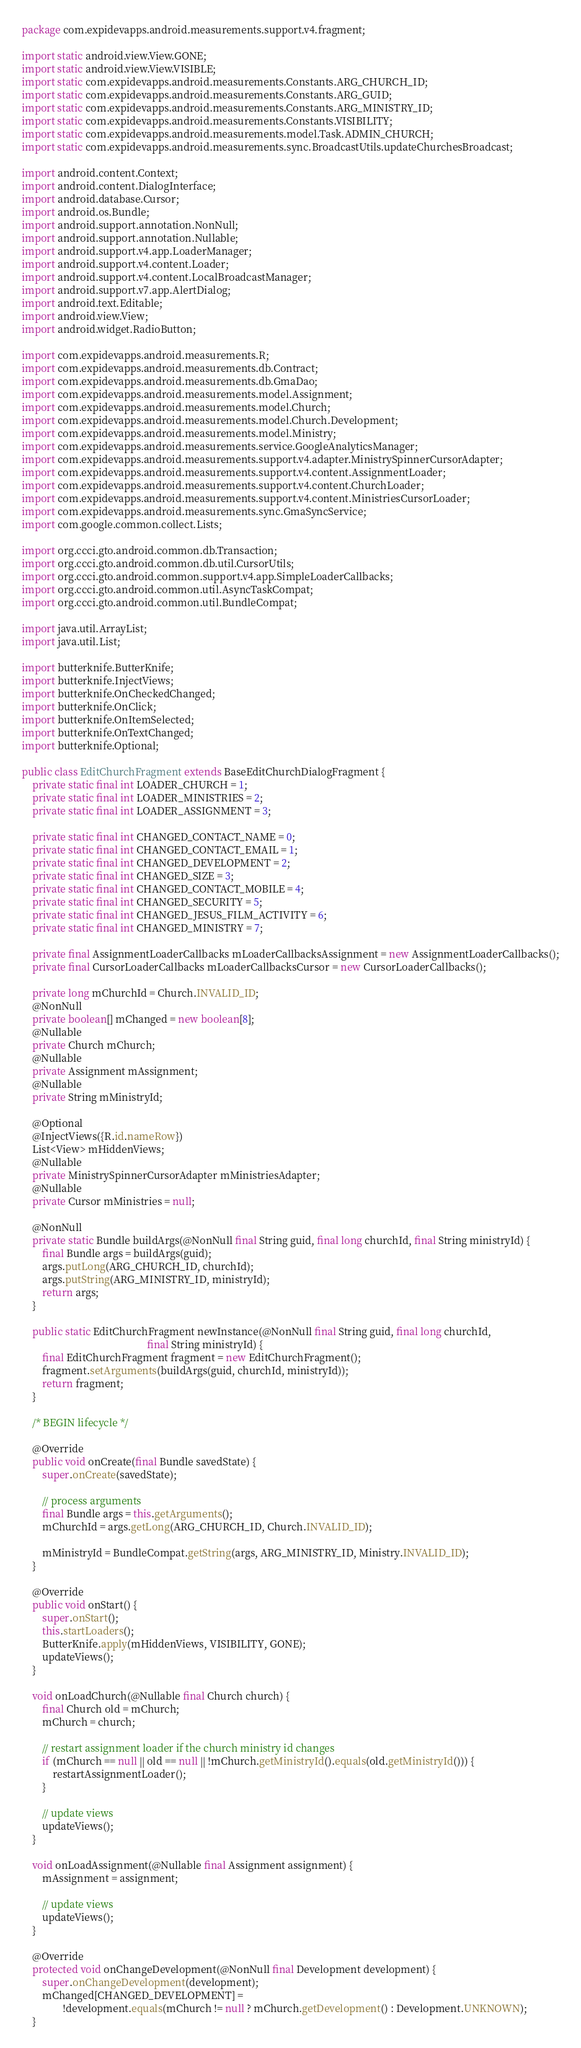Convert code to text. <code><loc_0><loc_0><loc_500><loc_500><_Java_>package com.expidevapps.android.measurements.support.v4.fragment;

import static android.view.View.GONE;
import static android.view.View.VISIBLE;
import static com.expidevapps.android.measurements.Constants.ARG_CHURCH_ID;
import static com.expidevapps.android.measurements.Constants.ARG_GUID;
import static com.expidevapps.android.measurements.Constants.ARG_MINISTRY_ID;
import static com.expidevapps.android.measurements.Constants.VISIBILITY;
import static com.expidevapps.android.measurements.model.Task.ADMIN_CHURCH;
import static com.expidevapps.android.measurements.sync.BroadcastUtils.updateChurchesBroadcast;

import android.content.Context;
import android.content.DialogInterface;
import android.database.Cursor;
import android.os.Bundle;
import android.support.annotation.NonNull;
import android.support.annotation.Nullable;
import android.support.v4.app.LoaderManager;
import android.support.v4.content.Loader;
import android.support.v4.content.LocalBroadcastManager;
import android.support.v7.app.AlertDialog;
import android.text.Editable;
import android.view.View;
import android.widget.RadioButton;

import com.expidevapps.android.measurements.R;
import com.expidevapps.android.measurements.db.Contract;
import com.expidevapps.android.measurements.db.GmaDao;
import com.expidevapps.android.measurements.model.Assignment;
import com.expidevapps.android.measurements.model.Church;
import com.expidevapps.android.measurements.model.Church.Development;
import com.expidevapps.android.measurements.model.Ministry;
import com.expidevapps.android.measurements.service.GoogleAnalyticsManager;
import com.expidevapps.android.measurements.support.v4.adapter.MinistrySpinnerCursorAdapter;
import com.expidevapps.android.measurements.support.v4.content.AssignmentLoader;
import com.expidevapps.android.measurements.support.v4.content.ChurchLoader;
import com.expidevapps.android.measurements.support.v4.content.MinistriesCursorLoader;
import com.expidevapps.android.measurements.sync.GmaSyncService;
import com.google.common.collect.Lists;

import org.ccci.gto.android.common.db.Transaction;
import org.ccci.gto.android.common.db.util.CursorUtils;
import org.ccci.gto.android.common.support.v4.app.SimpleLoaderCallbacks;
import org.ccci.gto.android.common.util.AsyncTaskCompat;
import org.ccci.gto.android.common.util.BundleCompat;

import java.util.ArrayList;
import java.util.List;

import butterknife.ButterKnife;
import butterknife.InjectViews;
import butterknife.OnCheckedChanged;
import butterknife.OnClick;
import butterknife.OnItemSelected;
import butterknife.OnTextChanged;
import butterknife.Optional;

public class EditChurchFragment extends BaseEditChurchDialogFragment {
    private static final int LOADER_CHURCH = 1;
    private static final int LOADER_MINISTRIES = 2;
    private static final int LOADER_ASSIGNMENT = 3;

    private static final int CHANGED_CONTACT_NAME = 0;
    private static final int CHANGED_CONTACT_EMAIL = 1;
    private static final int CHANGED_DEVELOPMENT = 2;
    private static final int CHANGED_SIZE = 3;
    private static final int CHANGED_CONTACT_MOBILE = 4;
    private static final int CHANGED_SECURITY = 5;
    private static final int CHANGED_JESUS_FILM_ACTIVITY = 6;
    private static final int CHANGED_MINISTRY = 7;

    private final AssignmentLoaderCallbacks mLoaderCallbacksAssignment = new AssignmentLoaderCallbacks();
    private final CursorLoaderCallbacks mLoaderCallbacksCursor = new CursorLoaderCallbacks();

    private long mChurchId = Church.INVALID_ID;
    @NonNull
    private boolean[] mChanged = new boolean[8];
    @Nullable
    private Church mChurch;
    @Nullable
    private Assignment mAssignment;
    @Nullable
    private String mMinistryId;

    @Optional
    @InjectViews({R.id.nameRow})
    List<View> mHiddenViews;
    @Nullable
    private MinistrySpinnerCursorAdapter mMinistriesAdapter;
    @Nullable
    private Cursor mMinistries = null;

    @NonNull
    private static Bundle buildArgs(@NonNull final String guid, final long churchId, final String ministryId) {
        final Bundle args = buildArgs(guid);
        args.putLong(ARG_CHURCH_ID, churchId);
        args.putString(ARG_MINISTRY_ID, ministryId);
        return args;
    }

    public static EditChurchFragment newInstance(@NonNull final String guid, final long churchId,
                                                 final String ministryId) {
        final EditChurchFragment fragment = new EditChurchFragment();
        fragment.setArguments(buildArgs(guid, churchId, ministryId));
        return fragment;
    }

    /* BEGIN lifecycle */

    @Override
    public void onCreate(final Bundle savedState) {
        super.onCreate(savedState);

        // process arguments
        final Bundle args = this.getArguments();
        mChurchId = args.getLong(ARG_CHURCH_ID, Church.INVALID_ID);

        mMinistryId = BundleCompat.getString(args, ARG_MINISTRY_ID, Ministry.INVALID_ID);
    }

    @Override
    public void onStart() {
        super.onStart();
        this.startLoaders();
        ButterKnife.apply(mHiddenViews, VISIBILITY, GONE);
        updateViews();
    }

    void onLoadChurch(@Nullable final Church church) {
        final Church old = mChurch;
        mChurch = church;

        // restart assignment loader if the church ministry id changes
        if (mChurch == null || old == null || !mChurch.getMinistryId().equals(old.getMinistryId())) {
            restartAssignmentLoader();
        }

        // update views
        updateViews();
    }

    void onLoadAssignment(@Nullable final Assignment assignment) {
        mAssignment = assignment;

        // update views
        updateViews();
    }

    @Override
    protected void onChangeDevelopment(@NonNull final Development development) {
        super.onChangeDevelopment(development);
        mChanged[CHANGED_DEVELOPMENT] =
                !development.equals(mChurch != null ? mChurch.getDevelopment() : Development.UNKNOWN);
    }
</code> 